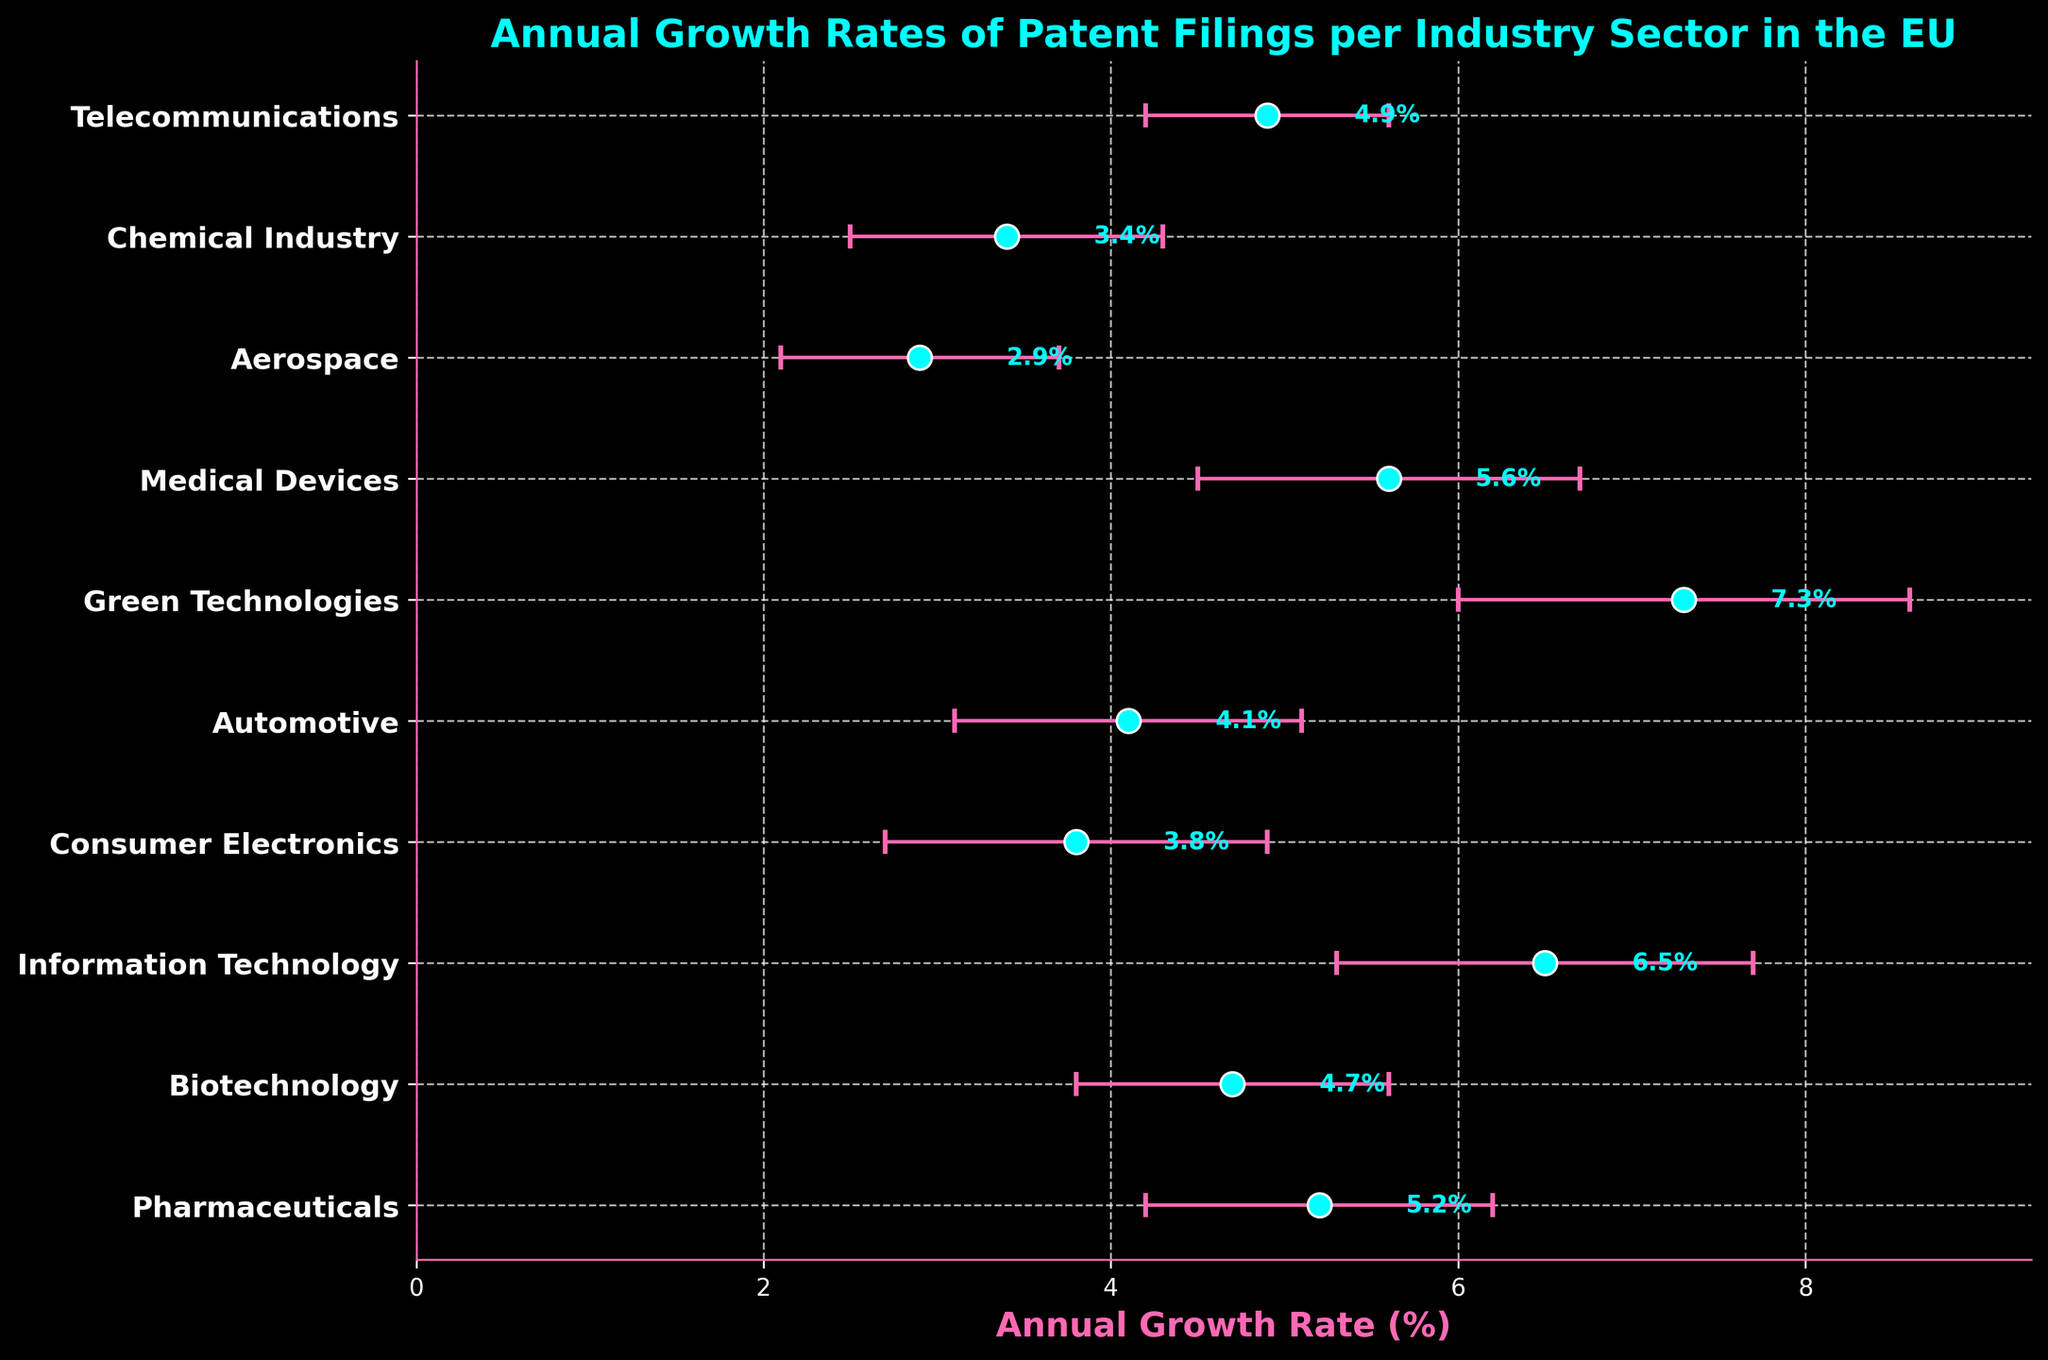What is the title of the plot? The title is displayed at the top of the plot in a larger, bold font. It provides a summary of the data being visualized. In this case, it is "Annual Growth Rates of Patent Filings per Industry Sector in the EU".
Answer: Annual Growth Rates of Patent Filings per Industry Sector in the EU Which industry sector has the highest annual growth rate? To find the highest annual growth rate, look for the data point furthest to the right. The dot representing Green Technologies has the highest value.
Answer: Green Technologies What is the range of annual growth rates displayed in the plot? To find the range, identify the smallest and largest growth rates shown. The smallest rate is for Aerospace at 2.9%, and the largest is for Green Technologies at 7.3%. Subtract the smallest from the largest: 7.3% - 2.9% = 4.4%.
Answer: 4.4% Which industry sector has the smallest standard deviation in its annual growth rate? Standard deviation is indicated by the length of the error bars, with shorter bars representing smaller deviations. Telecommunications has the shortest error bars at 0.7.
Answer: Telecommunications Compare the annual growth rates of Pharmaceuticals and Consumer Electronics. Which one is higher, and by how much? Check the x-axis positions of Pharmaceuticals (5.2%) and Consumer Electronics (3.8%). Pharmaceuticals is higher. Subtract to find the difference: 5.2% - 3.8% = 1.4%.
Answer: Pharmaceuticals, 1.4% Which industry sector has the most error-prone growth rate, as indicated by the largest standard deviation? Look for the sector with the longest error bars, indicating the largest standard deviation. Green Technologies has the longest at 1.3.
Answer: Green Technologies Are there any industry sectors with the same or nearly identical annual growth rates? Closely compare the x-axis positions of the dots. Pharmaceuticals (5.2%) and Medical Devices (5.6%) are close but not identical. Biotech (4.7%) and Automotive (4.1%) are also close but distinct.
Answer: No exact matches, but some close pairs If you average the annual growth rates of Pharmaceuticals, Biotechnology, and Information Technology, what is the result? Add their growth rates: 5.2% + 4.7% + 6.5% = 16.4%. Divide by the number of sectors (3): 16.4% / 3 = 5.47%.
Answer: 5.47% How does the annual growth rate of Automotive compare to Aerospace? The growth rate of Automotive is 4.1%, and Aerospace is 2.9%. Automotive is greater. Subtract Aerospace from Automotive: 4.1% - 2.9% = 1.2%.
Answer: Automotive is higher by 1.2% What is the relationship between the annual growth rates of Telecommunications and the Chemical Industry? Check the x-axis positions of Telecommunications (4.9%) and the Chemical Industry (3.4%). Telecommunications is greater. Subtract Chemical from Telecommunications: 4.9% - 3.4% = 1.5%.
Answer: Telecommunications is higher by 1.5% 